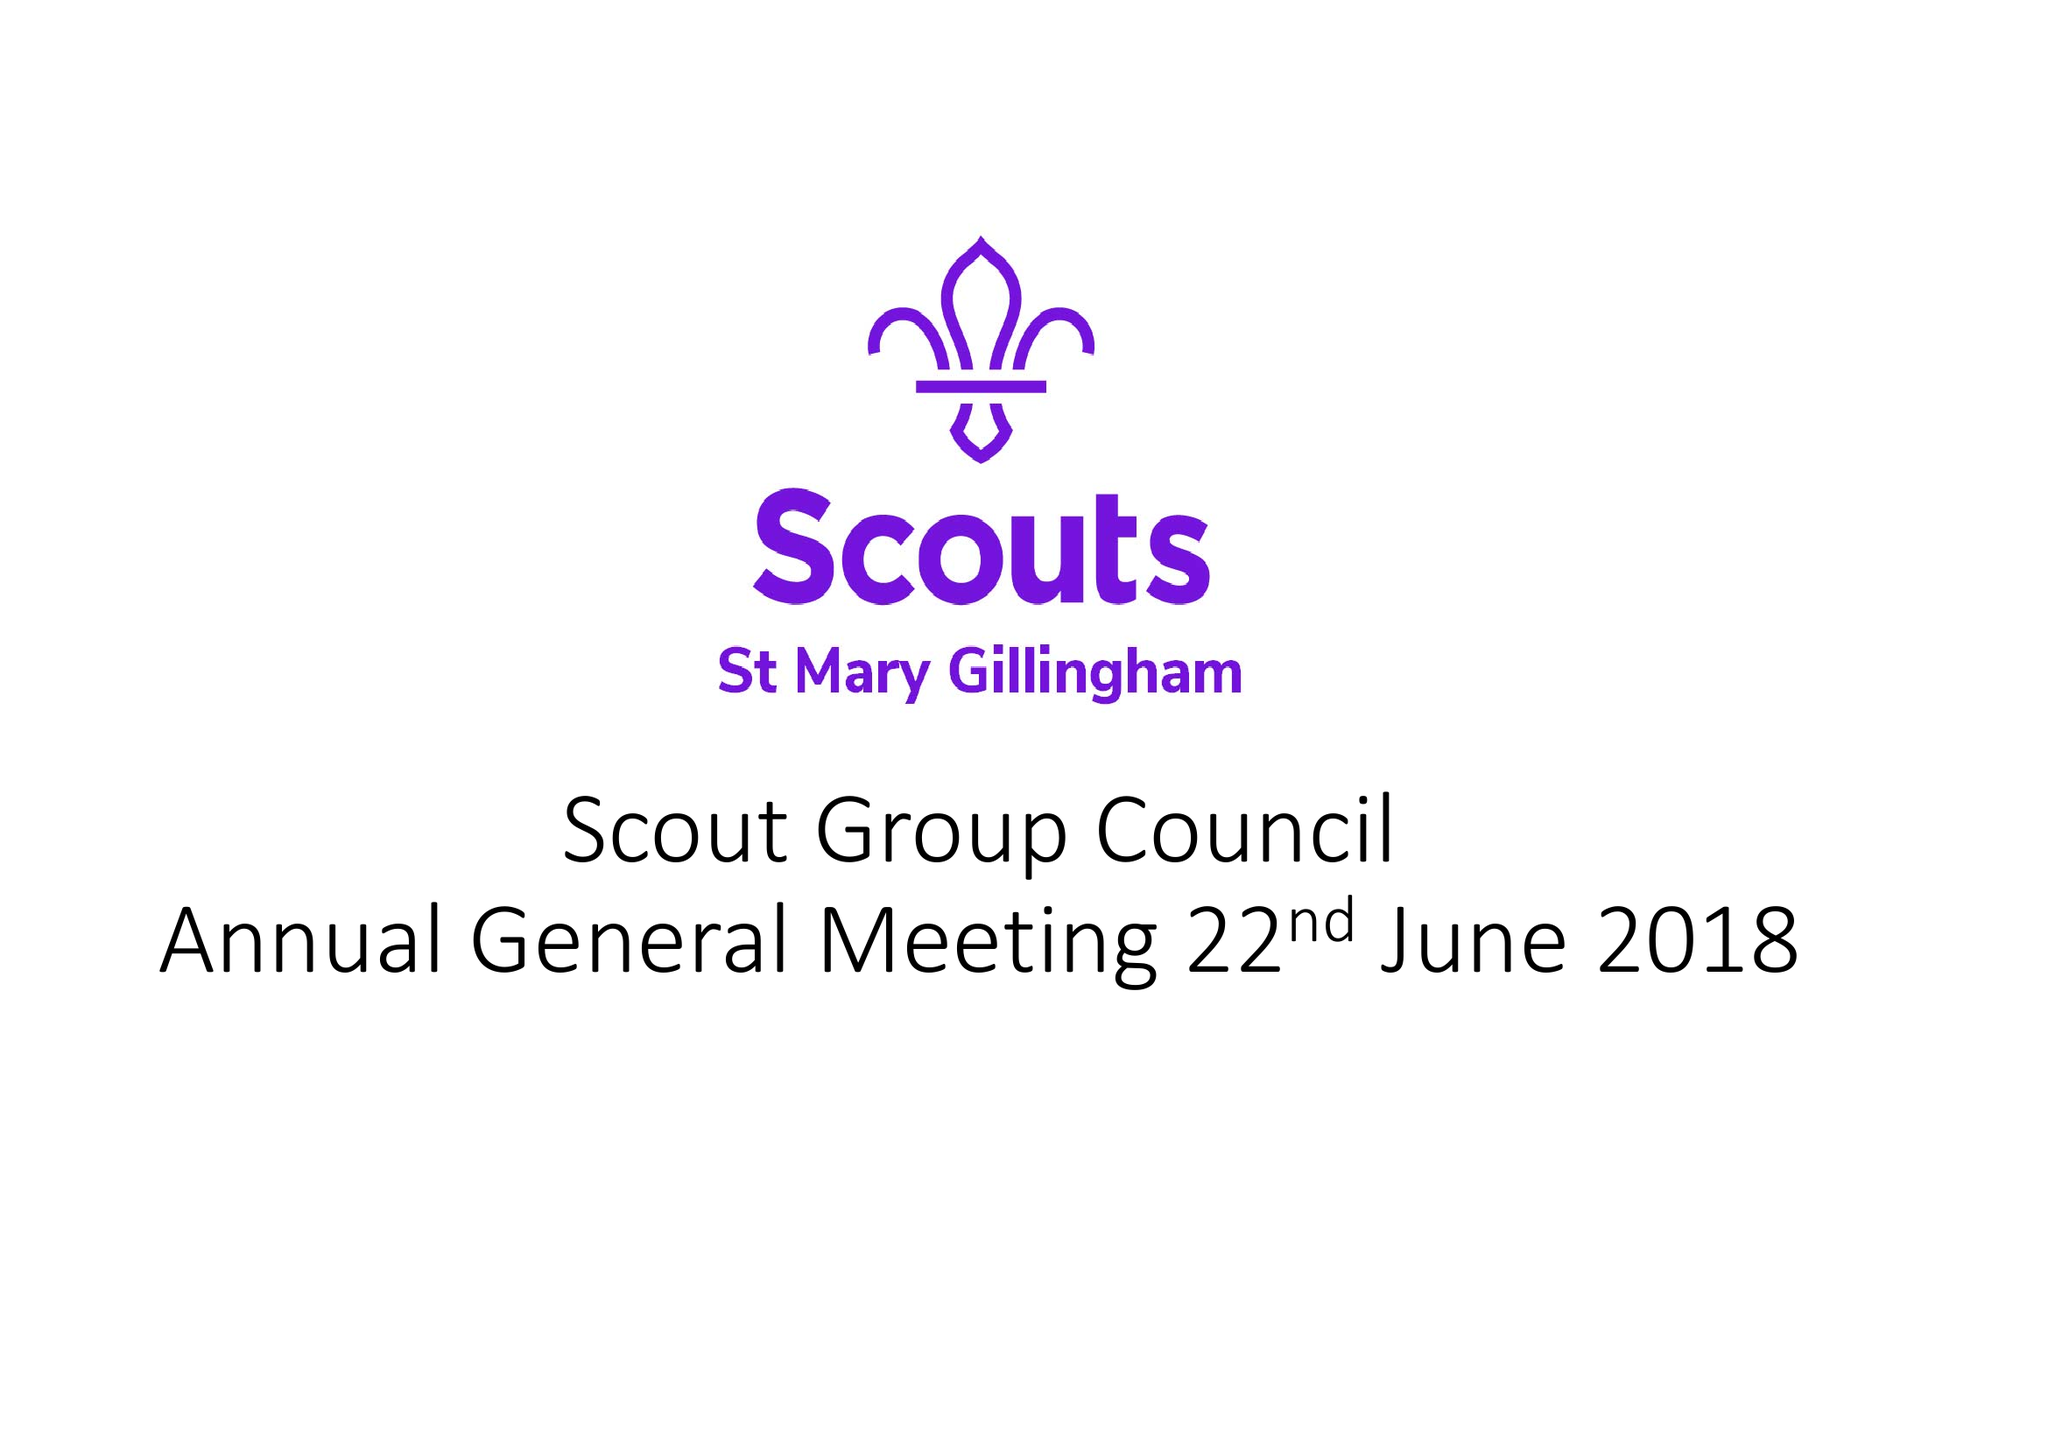What is the value for the address__postcode?
Answer the question using a single word or phrase. None 